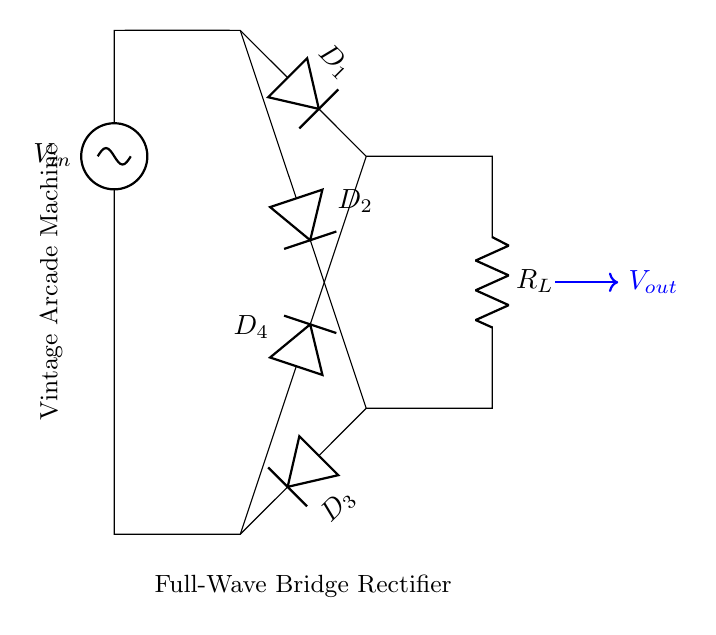What type of rectifier is shown? The circuit diagram illustrates a full-wave bridge rectifier, characterized by its configuration using four diodes arranged in a bridge formation to convert alternating current to direct current.
Answer: full-wave bridge rectifier How many diodes are in the circuit? There are four diodes present in the diagram. The four diodes are labeled D1, D2, D3, and D4, indicating their positions in the circuit for rectification.
Answer: four What is the purpose of the load resistor? The load resistor, labeled R_L in the circuit, serves the purpose of providing a load for the output voltage generated by the rectifier, allowing the generated current to flow through it and powering the connected device.
Answer: provide a load What is the output voltage direction relative to the input voltage? The output voltage, indicated as V_out, flows in the same direction regardless of the input voltage polarity due to the arrangement of the diodes in the bridge, making it a full-wave rectification.
Answer: same direction Which diodes conduct during positive input cycles? During the positive half cycles of the input voltage, diodes D1 and D2 conduct, allowing current to flow toward the load resistor, while diodes D3 and D4 remain off.
Answer: D1 and D2 Which component smooths the output voltage? While the circuit diagram does not show it, typically a capacitor is used after the bridge rectifier to smooth the output voltage by filtering out the ripples created from rectification, providing a more stable direct current.
Answer: capacitor 